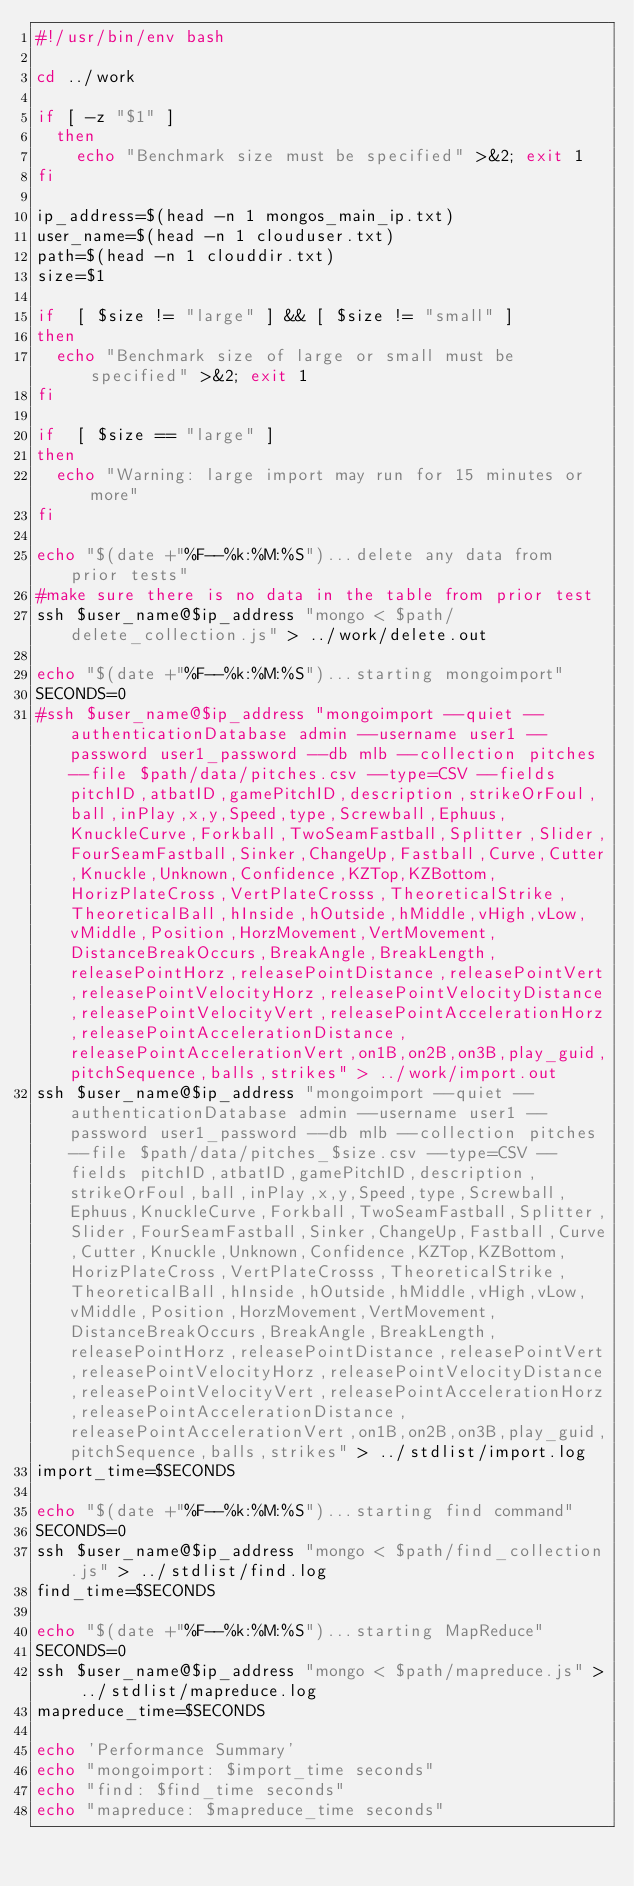<code> <loc_0><loc_0><loc_500><loc_500><_Bash_>#!/usr/bin/env bash

cd ../work

if [ -z "$1" ]
  then
    echo "Benchmark size must be specified" >&2; exit 1
fi

ip_address=$(head -n 1 mongos_main_ip.txt)
user_name=$(head -n 1 clouduser.txt)
path=$(head -n 1 clouddir.txt)
size=$1

if  [ $size != "large" ] && [ $size != "small" ]
then
  echo "Benchmark size of large or small must be specified" >&2; exit 1
fi

if  [ $size == "large" ] 
then
  echo "Warning: large import may run for 15 minutes or more"
fi

echo "$(date +"%F--%k:%M:%S")...delete any data from prior tests"
#make sure there is no data in the table from prior test
ssh $user_name@$ip_address "mongo < $path/delete_collection.js" > ../work/delete.out

echo "$(date +"%F--%k:%M:%S")...starting mongoimport"
SECONDS=0
#ssh $user_name@$ip_address "mongoimport --quiet --authenticationDatabase admin --username user1 --password user1_password --db mlb --collection pitches --file $path/data/pitches.csv --type=CSV --fields pitchID,atbatID,gamePitchID,description,strikeOrFoul,ball,inPlay,x,y,Speed,type,Screwball,Ephuus,KnuckleCurve,Forkball,TwoSeamFastball,Splitter,Slider,FourSeamFastball,Sinker,ChangeUp,Fastball,Curve,Cutter,Knuckle,Unknown,Confidence,KZTop,KZBottom,HorizPlateCross,VertPlateCrosss,TheoreticalStrike,TheoreticalBall,hInside,hOutside,hMiddle,vHigh,vLow,vMiddle,Position,HorzMovement,VertMovement,DistanceBreakOccurs,BreakAngle,BreakLength,releasePointHorz,releasePointDistance,releasePointVert,releasePointVelocityHorz,releasePointVelocityDistance,releasePointVelocityVert,releasePointAccelerationHorz,releasePointAccelerationDistance,releasePointAccelerationVert,on1B,on2B,on3B,play_guid,pitchSequence,balls,strikes" > ../work/import.out
ssh $user_name@$ip_address "mongoimport --quiet --authenticationDatabase admin --username user1 --password user1_password --db mlb --collection pitches --file $path/data/pitches_$size.csv --type=CSV --fields pitchID,atbatID,gamePitchID,description,strikeOrFoul,ball,inPlay,x,y,Speed,type,Screwball,Ephuus,KnuckleCurve,Forkball,TwoSeamFastball,Splitter,Slider,FourSeamFastball,Sinker,ChangeUp,Fastball,Curve,Cutter,Knuckle,Unknown,Confidence,KZTop,KZBottom,HorizPlateCross,VertPlateCrosss,TheoreticalStrike,TheoreticalBall,hInside,hOutside,hMiddle,vHigh,vLow,vMiddle,Position,HorzMovement,VertMovement,DistanceBreakOccurs,BreakAngle,BreakLength,releasePointHorz,releasePointDistance,releasePointVert,releasePointVelocityHorz,releasePointVelocityDistance,releasePointVelocityVert,releasePointAccelerationHorz,releasePointAccelerationDistance,releasePointAccelerationVert,on1B,on2B,on3B,play_guid,pitchSequence,balls,strikes" > ../stdlist/import.log
import_time=$SECONDS

echo "$(date +"%F--%k:%M:%S")...starting find command"
SECONDS=0
ssh $user_name@$ip_address "mongo < $path/find_collection.js" > ../stdlist/find.log
find_time=$SECONDS

echo "$(date +"%F--%k:%M:%S")...starting MapReduce"
SECONDS=0
ssh $user_name@$ip_address "mongo < $path/mapreduce.js" > ../stdlist/mapreduce.log
mapreduce_time=$SECONDS

echo 'Performance Summary'
echo "mongoimport: $import_time seconds"
echo "find: $find_time seconds"
echo "mapreduce: $mapreduce_time seconds"
</code> 